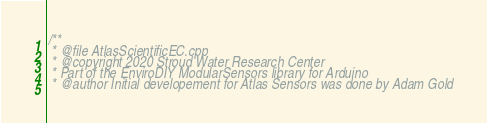<code> <loc_0><loc_0><loc_500><loc_500><_C++_>/**
 * @file AtlasScientificEC.cpp
 * @copyright 2020 Stroud Water Research Center
 * Part of the EnviroDIY ModularSensors library for Arduino
 * @author Initial developement for Atlas Sensors was done by Adam Gold</code> 